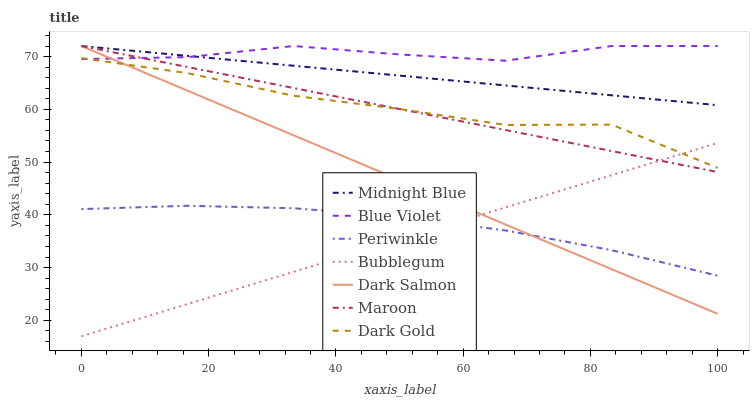Does Bubblegum have the minimum area under the curve?
Answer yes or no. Yes. Does Blue Violet have the maximum area under the curve?
Answer yes or no. Yes. Does Dark Gold have the minimum area under the curve?
Answer yes or no. No. Does Dark Gold have the maximum area under the curve?
Answer yes or no. No. Is Maroon the smoothest?
Answer yes or no. Yes. Is Dark Gold the roughest?
Answer yes or no. Yes. Is Dark Salmon the smoothest?
Answer yes or no. No. Is Dark Salmon the roughest?
Answer yes or no. No. Does Bubblegum have the lowest value?
Answer yes or no. Yes. Does Dark Gold have the lowest value?
Answer yes or no. No. Does Blue Violet have the highest value?
Answer yes or no. Yes. Does Dark Gold have the highest value?
Answer yes or no. No. Is Periwinkle less than Dark Gold?
Answer yes or no. Yes. Is Midnight Blue greater than Periwinkle?
Answer yes or no. Yes. Does Blue Violet intersect Midnight Blue?
Answer yes or no. Yes. Is Blue Violet less than Midnight Blue?
Answer yes or no. No. Is Blue Violet greater than Midnight Blue?
Answer yes or no. No. Does Periwinkle intersect Dark Gold?
Answer yes or no. No. 